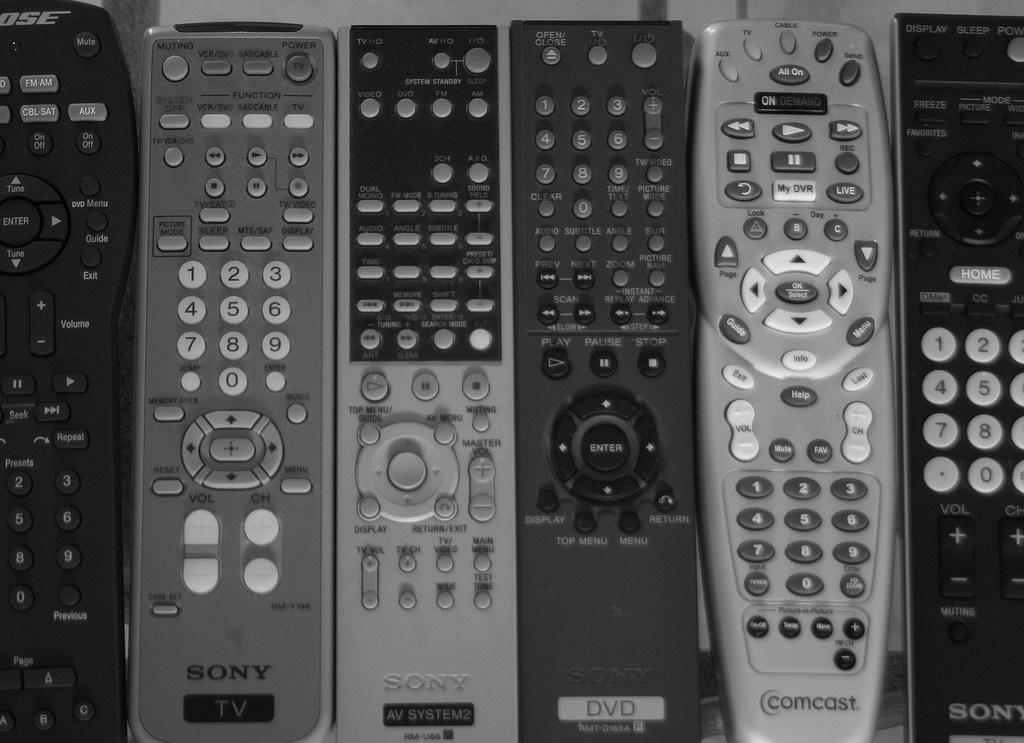Could you give a brief overview of what you see in this image? In this image I can see few remotes which are in black, ash and grey color. These are on the white and ash color surface. 